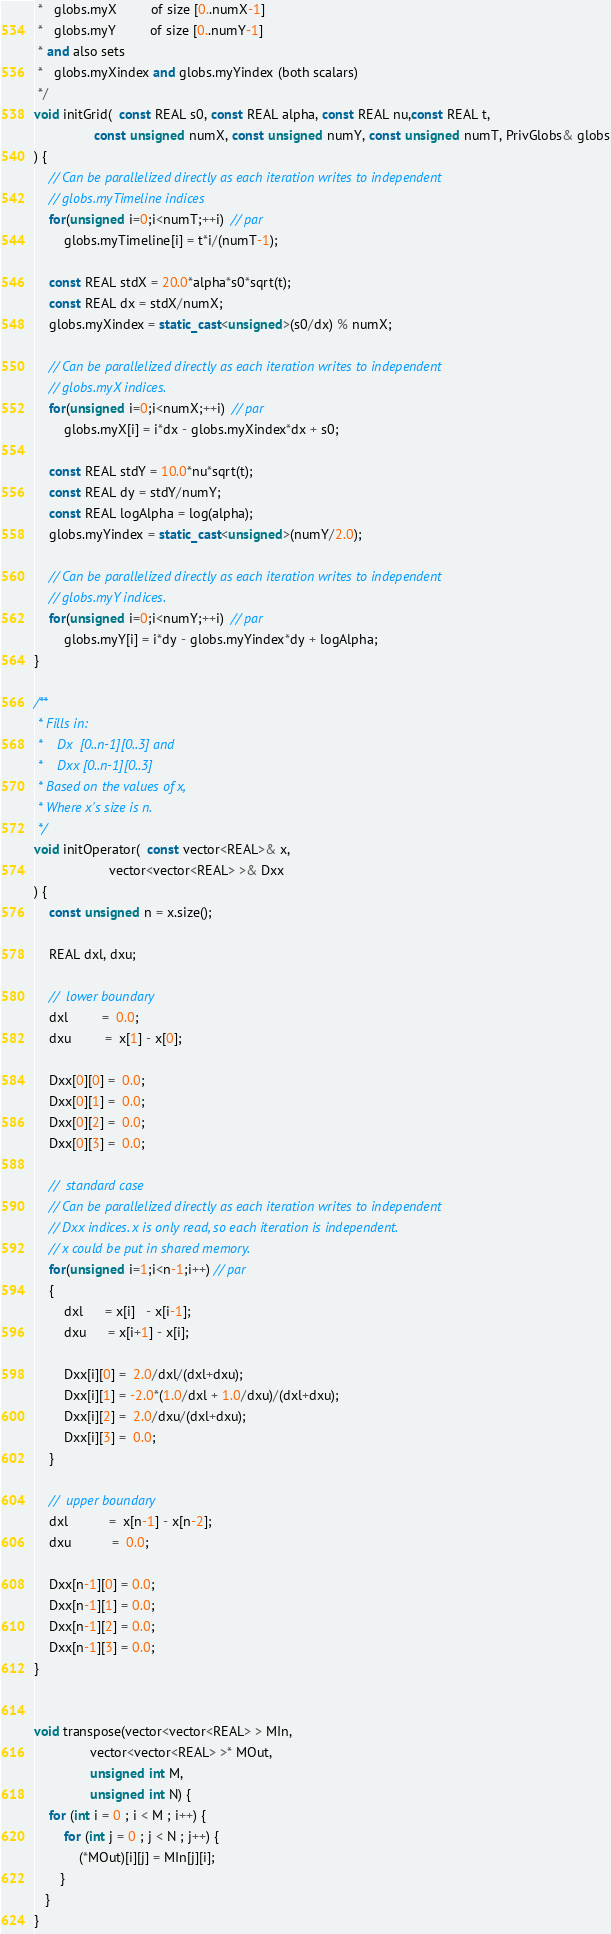<code> <loc_0><loc_0><loc_500><loc_500><_C++_> *   globs.myX         of size [0..numX-1]
 *   globs.myY         of size [0..numY-1]
 * and also sets
 *   globs.myXindex and globs.myYindex (both scalars)
 */
void initGrid(  const REAL s0, const REAL alpha, const REAL nu,const REAL t,
                const unsigned numX, const unsigned numY, const unsigned numT, PrivGlobs& globs
) {
    // Can be parallelized directly as each iteration writes to independent
    // globs.myTimeline indices
    for(unsigned i=0;i<numT;++i)  // par
        globs.myTimeline[i] = t*i/(numT-1);

    const REAL stdX = 20.0*alpha*s0*sqrt(t);
    const REAL dx = stdX/numX;
    globs.myXindex = static_cast<unsigned>(s0/dx) % numX;

    // Can be parallelized directly as each iteration writes to independent
    // globs.myX indices.
    for(unsigned i=0;i<numX;++i)  // par
        globs.myX[i] = i*dx - globs.myXindex*dx + s0;

    const REAL stdY = 10.0*nu*sqrt(t);
    const REAL dy = stdY/numY;
    const REAL logAlpha = log(alpha);
    globs.myYindex = static_cast<unsigned>(numY/2.0);

    // Can be parallelized directly as each iteration writes to independent
    // globs.myY indices.
    for(unsigned i=0;i<numY;++i)  // par
        globs.myY[i] = i*dy - globs.myYindex*dy + logAlpha;
}

/**
 * Fills in:
 *    Dx  [0..n-1][0..3] and
 *    Dxx [0..n-1][0..3]
 * Based on the values of x,
 * Where x's size is n.
 */
void initOperator(  const vector<REAL>& x,
                    vector<vector<REAL> >& Dxx
) {
	const unsigned n = x.size();

	REAL dxl, dxu;

	//	lower boundary
	dxl		 =  0.0;
	dxu		 =  x[1] - x[0];

	Dxx[0][0] =  0.0;
	Dxx[0][1] =  0.0;
	Dxx[0][2] =  0.0;
    Dxx[0][3] =  0.0;

	//	standard case
    // Can be parallelized directly as each iteration writes to independent
    // Dxx indices. x is only read, so each iteration is independent.
    // x could be put in shared memory.
	for(unsigned i=1;i<n-1;i++) // par
	{
		dxl      = x[i]   - x[i-1];
		dxu      = x[i+1] - x[i];

		Dxx[i][0] =  2.0/dxl/(dxl+dxu);
		Dxx[i][1] = -2.0*(1.0/dxl + 1.0/dxu)/(dxl+dxu);
		Dxx[i][2] =  2.0/dxu/(dxl+dxu);
        Dxx[i][3] =  0.0;
	}

	//	upper boundary
	dxl		   =  x[n-1] - x[n-2];
	dxu		   =  0.0;

	Dxx[n-1][0] = 0.0;
	Dxx[n-1][1] = 0.0;
	Dxx[n-1][2] = 0.0;
    Dxx[n-1][3] = 0.0;
}


void transpose(vector<vector<REAL> > MIn,
               vector<vector<REAL> >* MOut,
               unsigned int M,
               unsigned int N) {
    for (int i = 0 ; i < M ; i++) {
        for (int j = 0 ; j < N ; j++) {
            (*MOut)[i][j] = MIn[j][i];
       }
   }
}
</code> 